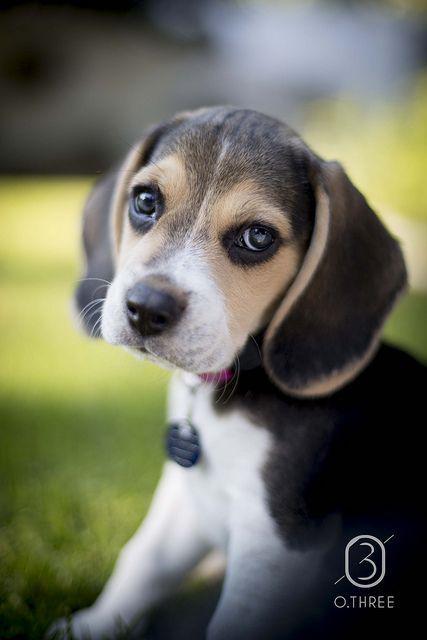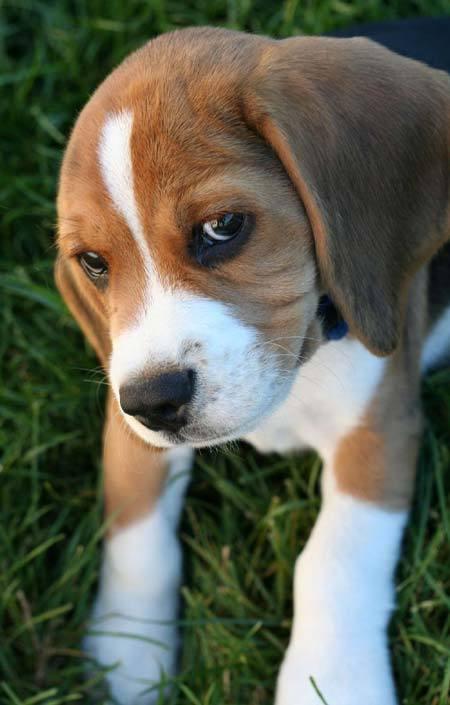The first image is the image on the left, the second image is the image on the right. Assess this claim about the two images: "An image shows a sitting beagle eyeing the camera, with a tag dangling from its collar.". Correct or not? Answer yes or no. Yes. The first image is the image on the left, the second image is the image on the right. Considering the images on both sides, is "In the right image, the beagle wears a leash." valid? Answer yes or no. No. 